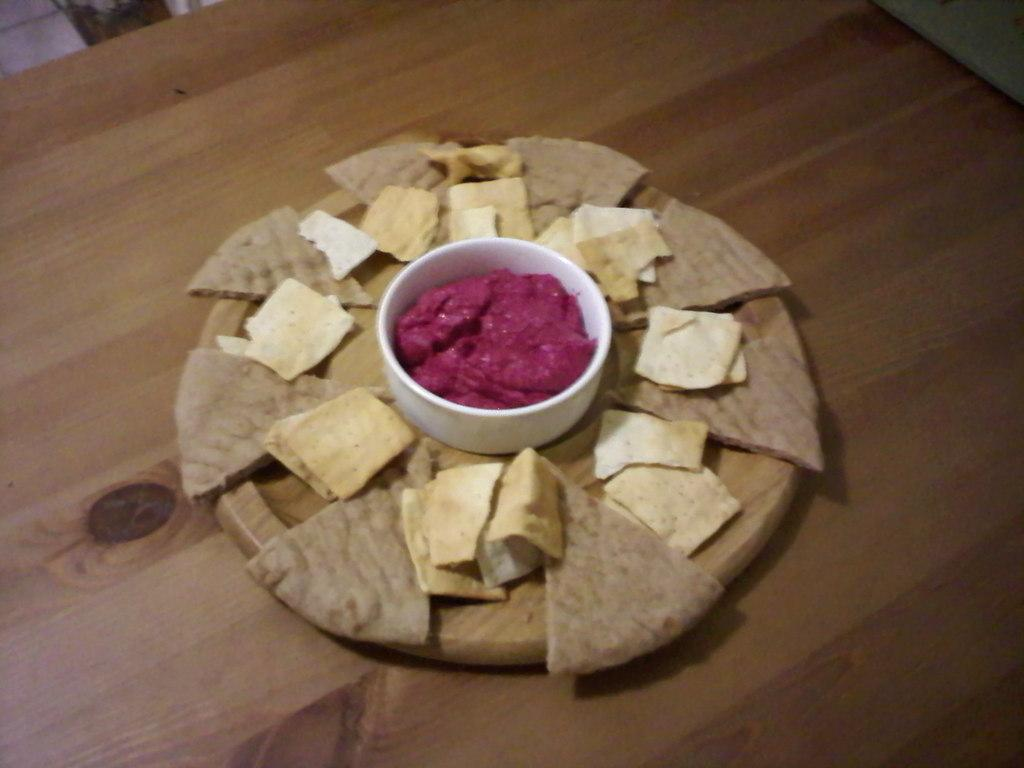What is present in the image that represents a meal or dish? There is food in the image. What type of container is holding the food? There is a bowl in the image. How is the bowl positioned in relation to another object? The bowl is placed on a plate. On what surface is the plate resting? The plate is placed on a table. Where are the bushes located in the image? There are no bushes present in the image. What type of seed is being used to grow the bucket in the image? There is no bucket or seed present in the image. 